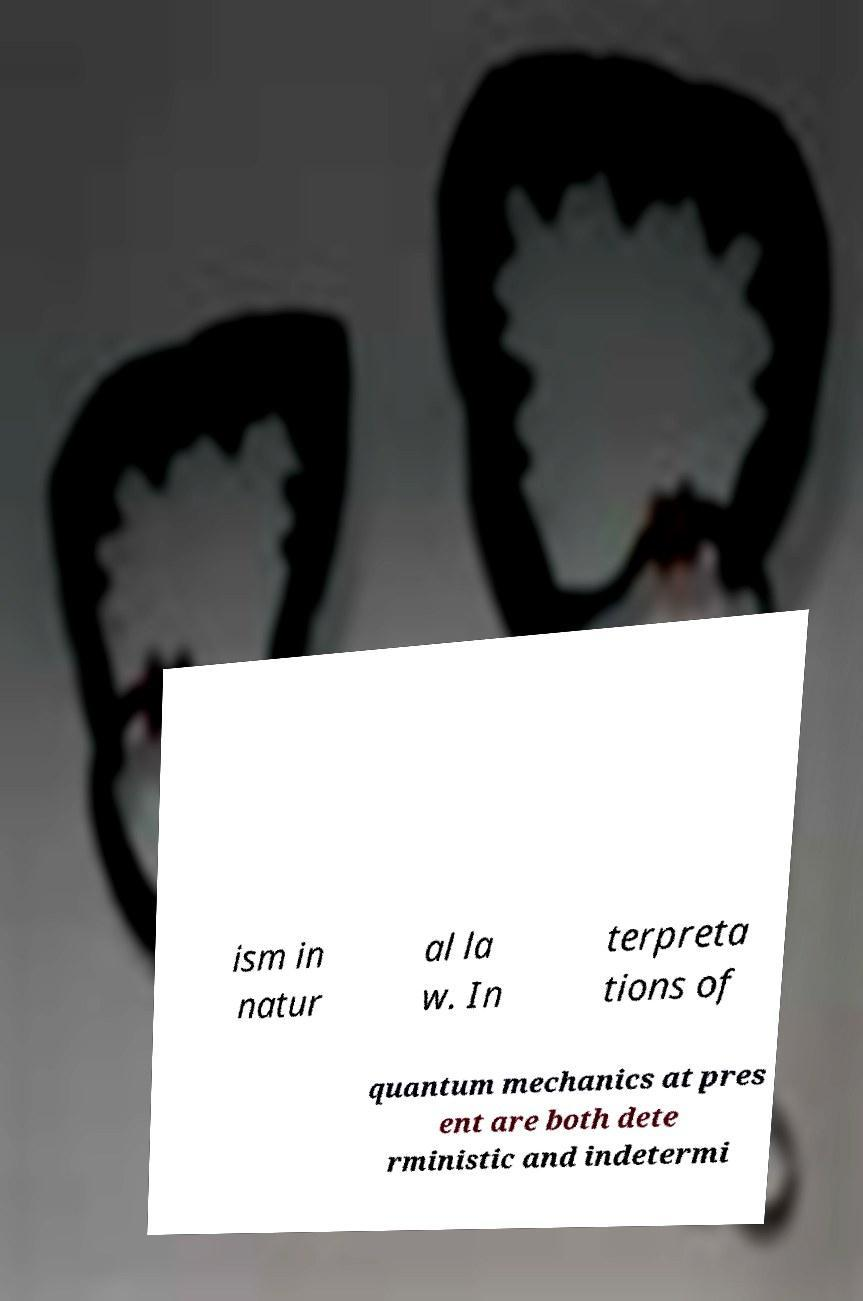Could you extract and type out the text from this image? ism in natur al la w. In terpreta tions of quantum mechanics at pres ent are both dete rministic and indetermi 